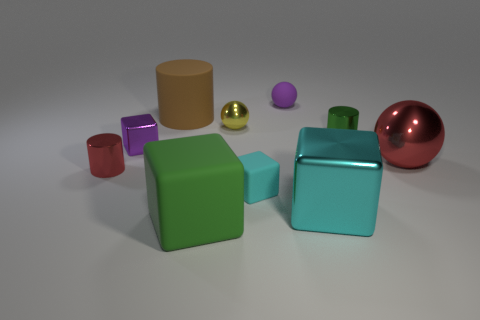Subtract all yellow blocks. Subtract all brown cylinders. How many blocks are left? 4 Subtract all cylinders. How many objects are left? 7 Subtract all small metal cylinders. Subtract all brown things. How many objects are left? 7 Add 2 small purple spheres. How many small purple spheres are left? 3 Add 8 red cylinders. How many red cylinders exist? 9 Subtract 1 purple cubes. How many objects are left? 9 